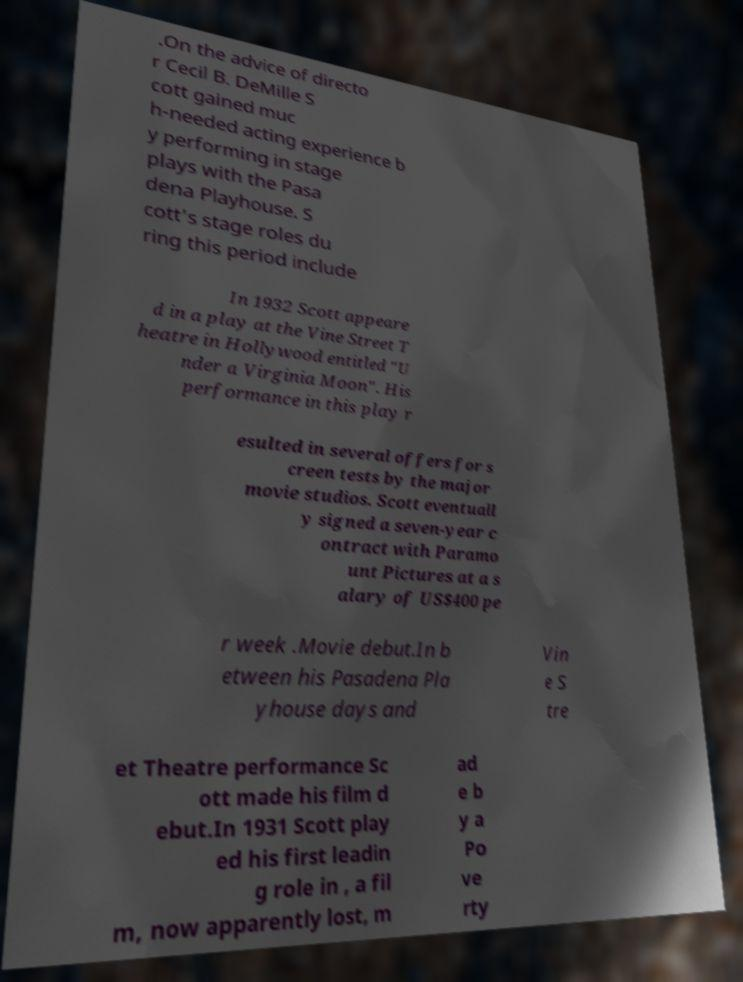There's text embedded in this image that I need extracted. Can you transcribe it verbatim? .On the advice of directo r Cecil B. DeMille S cott gained muc h-needed acting experience b y performing in stage plays with the Pasa dena Playhouse. S cott's stage roles du ring this period include In 1932 Scott appeare d in a play at the Vine Street T heatre in Hollywood entitled "U nder a Virginia Moon". His performance in this play r esulted in several offers for s creen tests by the major movie studios. Scott eventuall y signed a seven-year c ontract with Paramo unt Pictures at a s alary of US$400 pe r week .Movie debut.In b etween his Pasadena Pla yhouse days and Vin e S tre et Theatre performance Sc ott made his film d ebut.In 1931 Scott play ed his first leadin g role in , a fil m, now apparently lost, m ad e b y a Po ve rty 